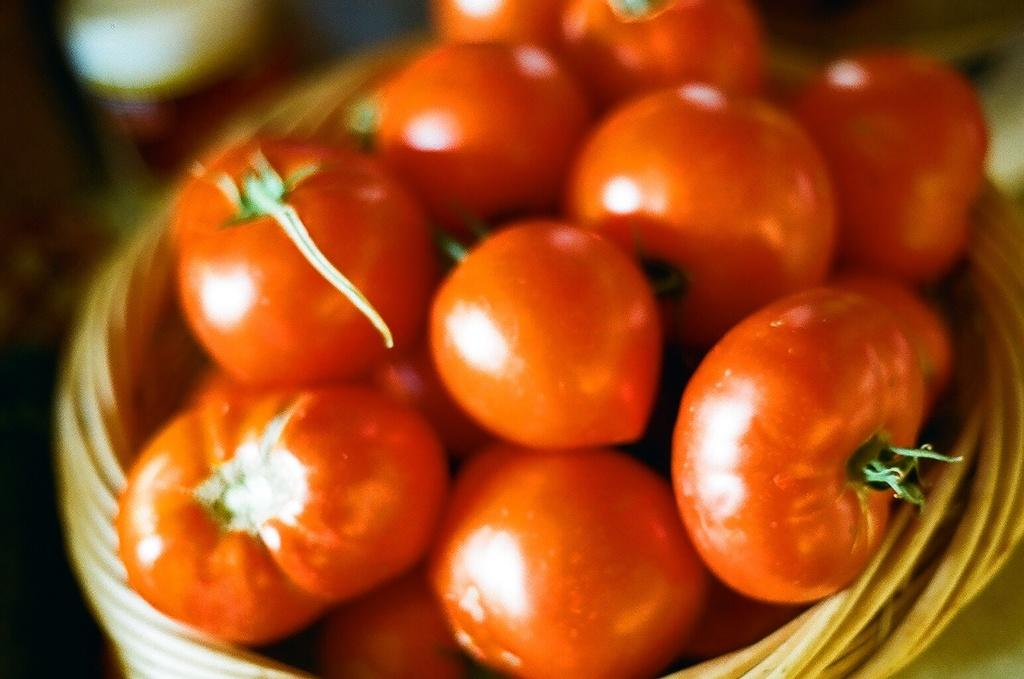What type of fruit is present in the image? There are tomatoes in the image. How are the tomatoes arranged or contained in the image? The tomatoes are in a basket. What type of coil can be seen in the image? There is no coil present in the image; it features tomatoes in a basket. Are there any grapes visible in the image? No, there are no grapes present in the image; it features tomatoes in a basket. 